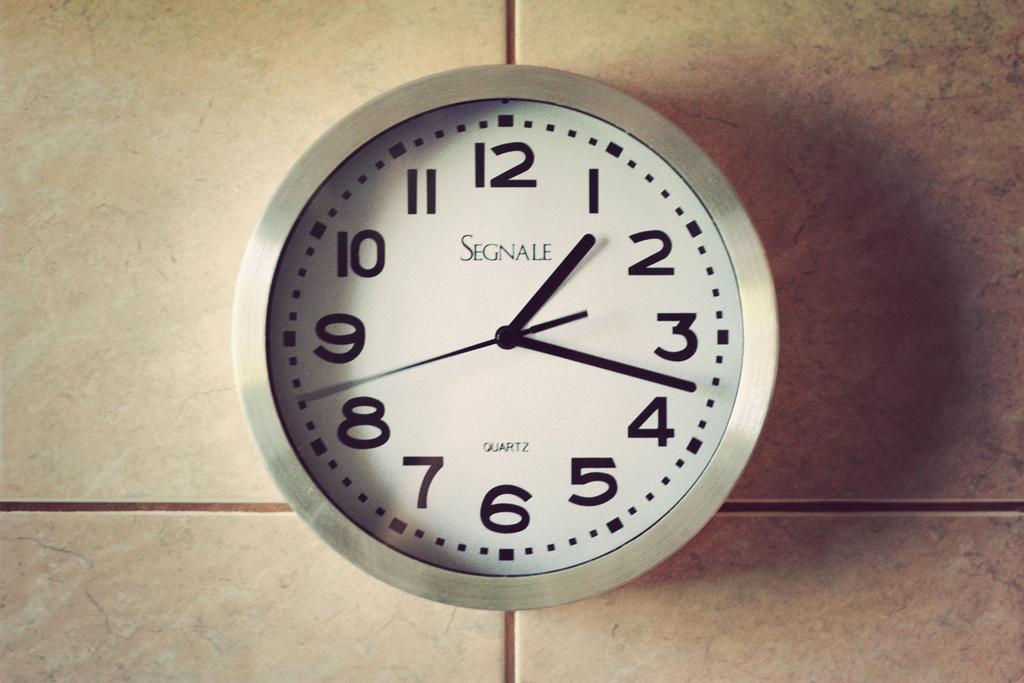What time is shown on the clock?
Keep it short and to the point. 1:17. What brand is the clock?
Your answer should be very brief. Segnale. 